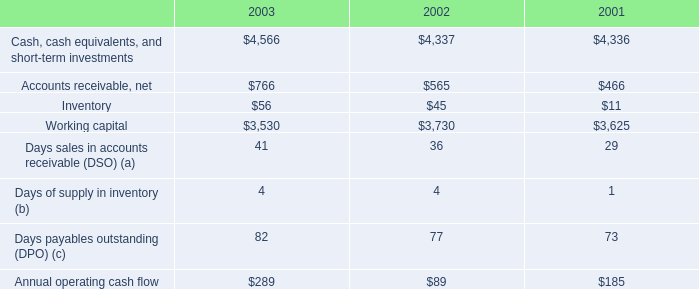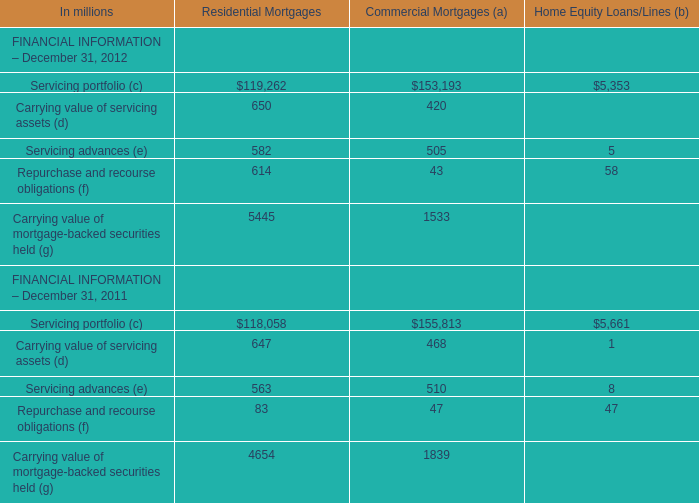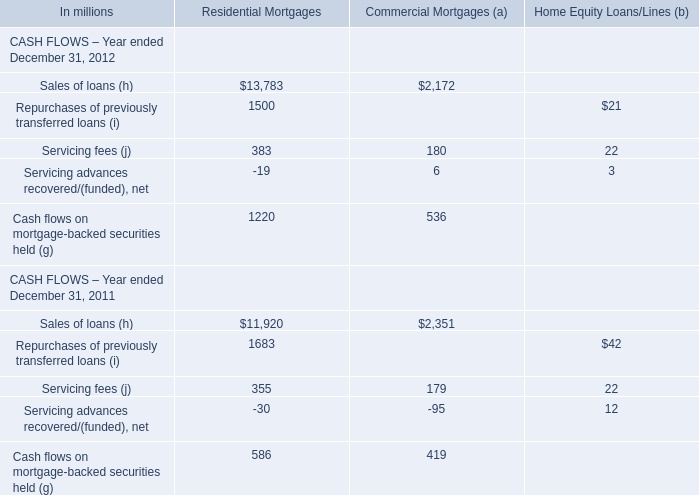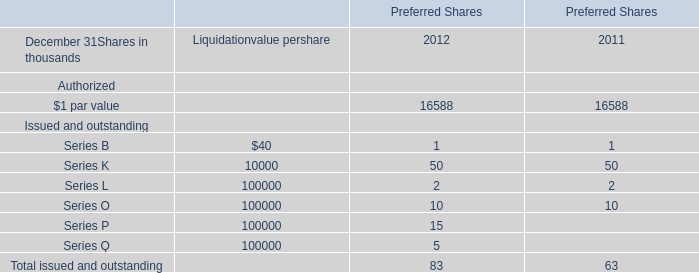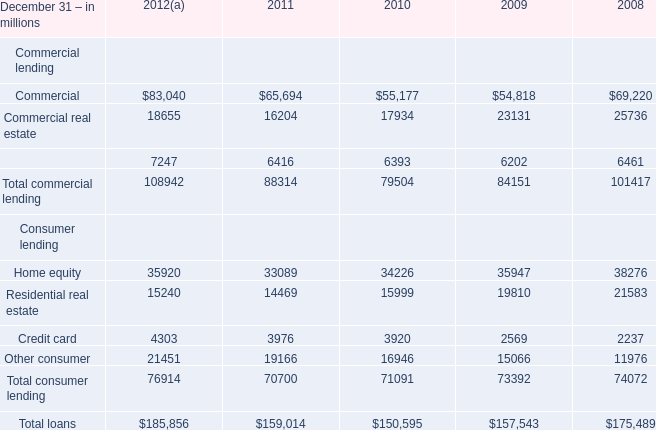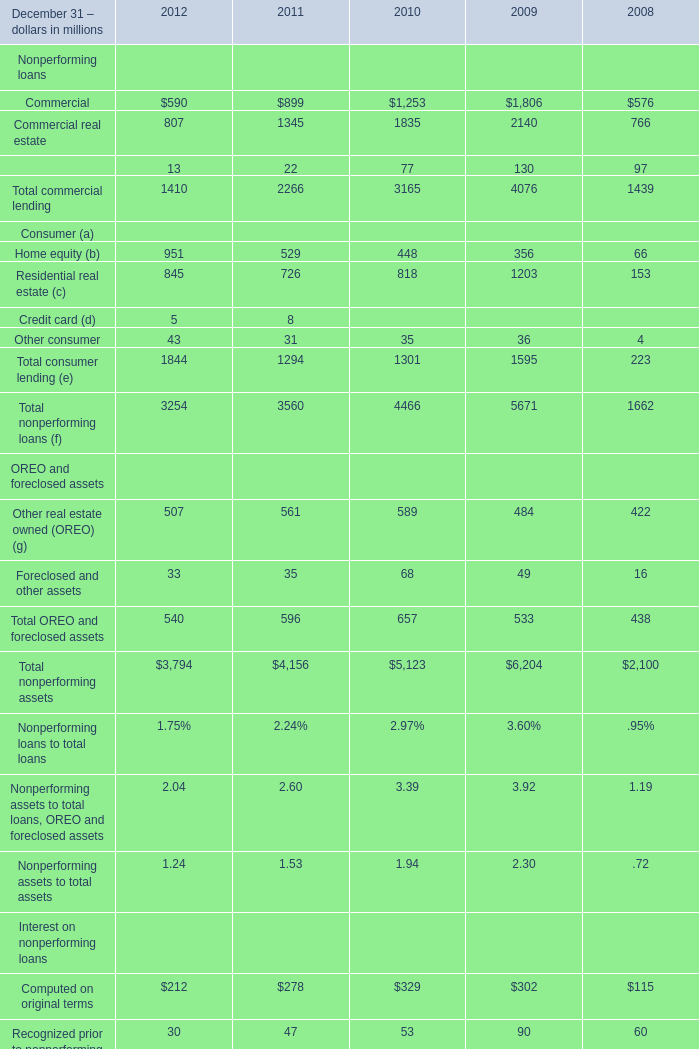In the year with the most Commercial, what is the growth rate of Equipment lease financing? 
Computations: ((130 - 97) / 130)
Answer: 0.25385. 